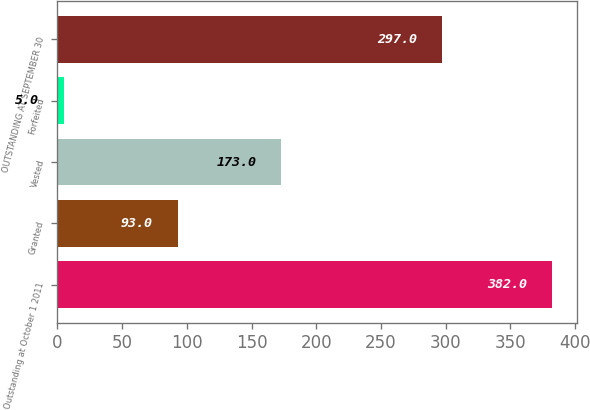<chart> <loc_0><loc_0><loc_500><loc_500><bar_chart><fcel>Outstanding at October 1 2011<fcel>Granted<fcel>Vested<fcel>Forfeited<fcel>OUTSTANDING AT SEPTEMBER 30<nl><fcel>382<fcel>93<fcel>173<fcel>5<fcel>297<nl></chart> 